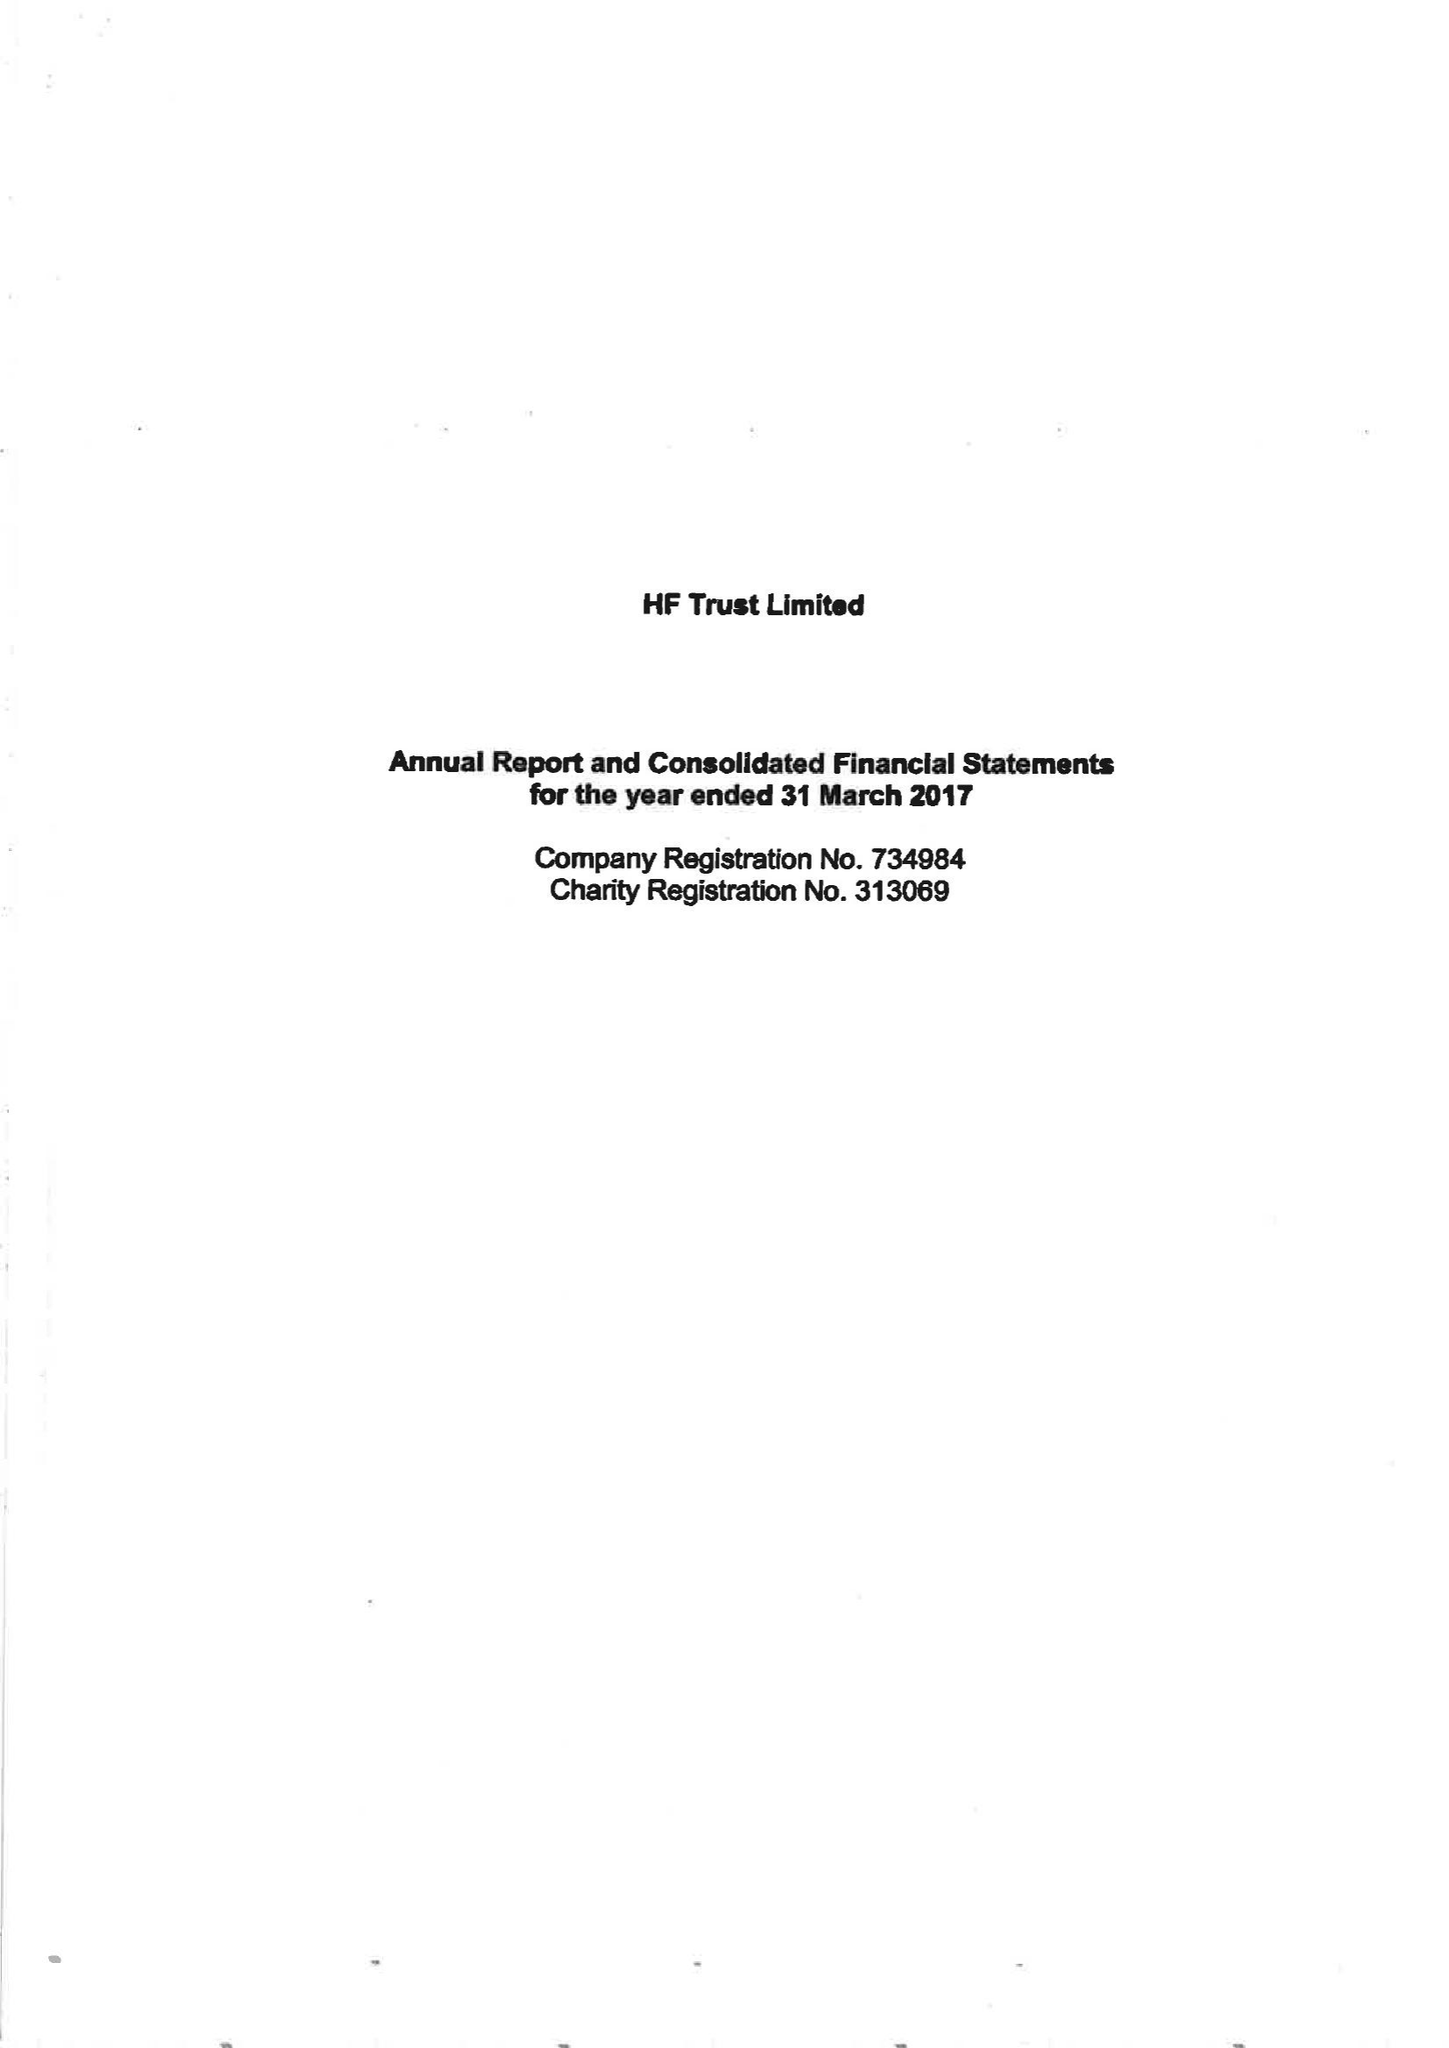What is the value for the address__postcode?
Answer the question using a single word or phrase. BS16 7FL 